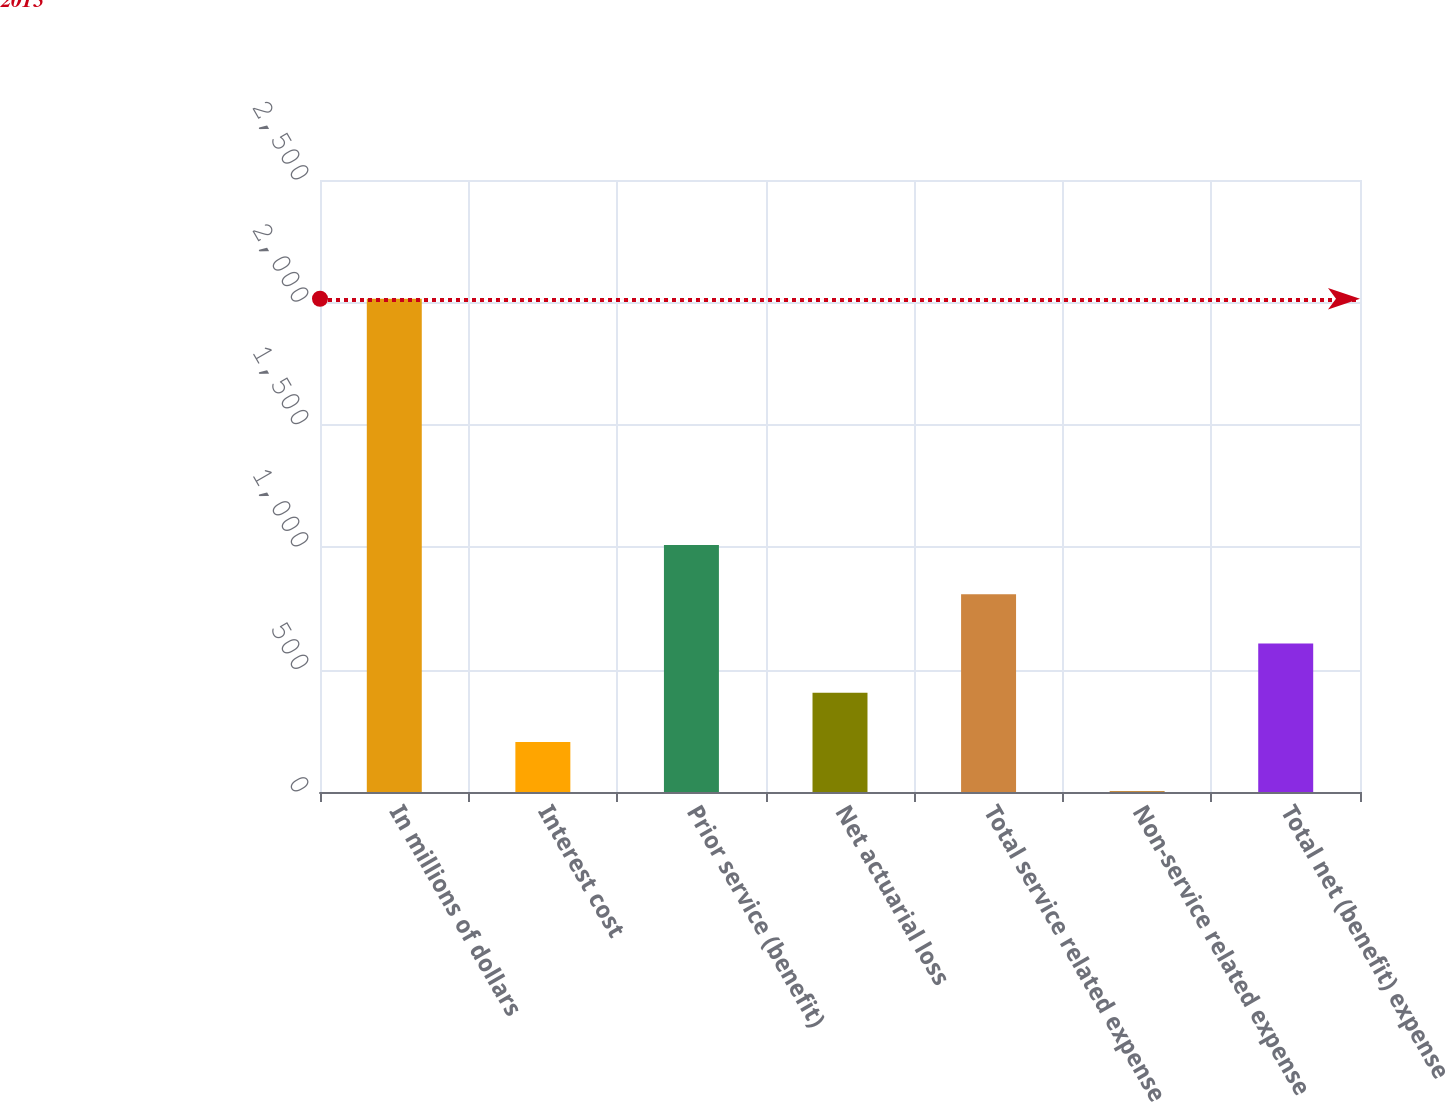Convert chart. <chart><loc_0><loc_0><loc_500><loc_500><bar_chart><fcel>In millions of dollars<fcel>Interest cost<fcel>Prior service (benefit)<fcel>Net actuarial loss<fcel>Total service related expense<fcel>Non-service related expense<fcel>Total net (benefit) expense<nl><fcel>2015<fcel>204.2<fcel>1009<fcel>405.4<fcel>807.8<fcel>3<fcel>606.6<nl></chart> 